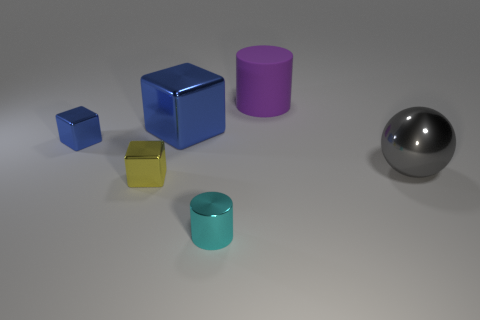Subtract 1 balls. How many balls are left? 0 Subtract all tiny cubes. How many cubes are left? 1 Add 1 blue rubber blocks. How many objects exist? 7 Subtract 0 blue cylinders. How many objects are left? 6 Subtract all cylinders. How many objects are left? 4 Subtract all cyan cylinders. Subtract all green spheres. How many cylinders are left? 1 Subtract all gray cubes. How many yellow spheres are left? 0 Subtract all tiny purple objects. Subtract all large blocks. How many objects are left? 5 Add 3 tiny objects. How many tiny objects are left? 6 Add 4 small gray blocks. How many small gray blocks exist? 4 